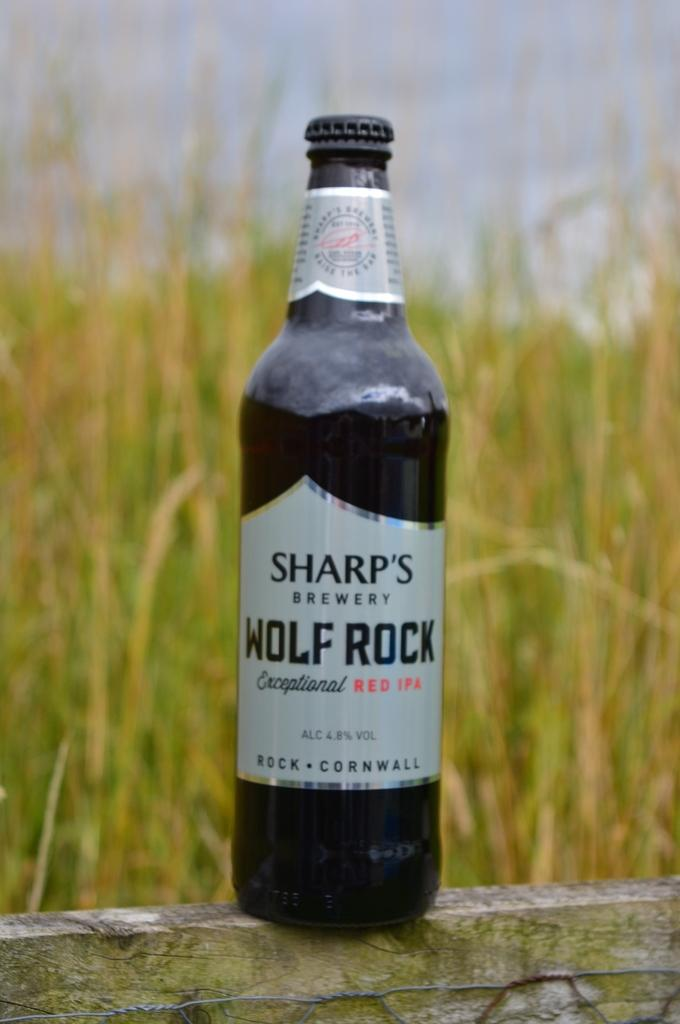<image>
Create a compact narrative representing the image presented. the name Sharp's that is on a beer bottle 